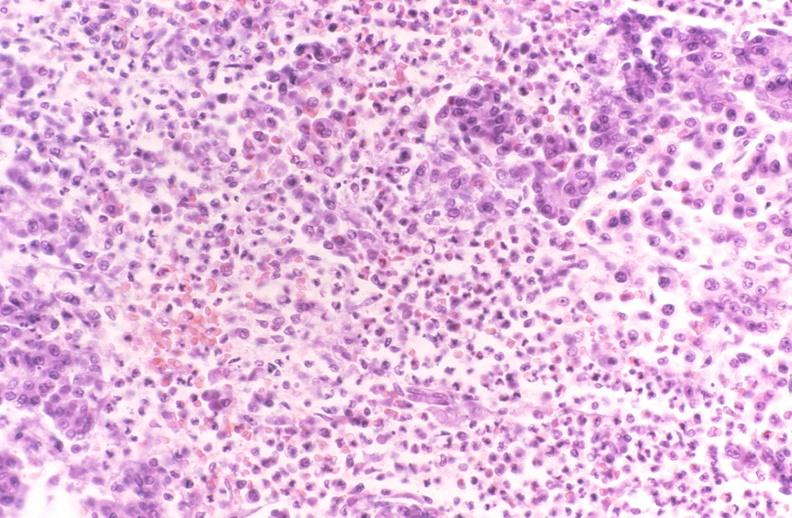does this image show pancreatic fat necrosis, pancreatitis/necrosis?
Answer the question using a single word or phrase. Yes 